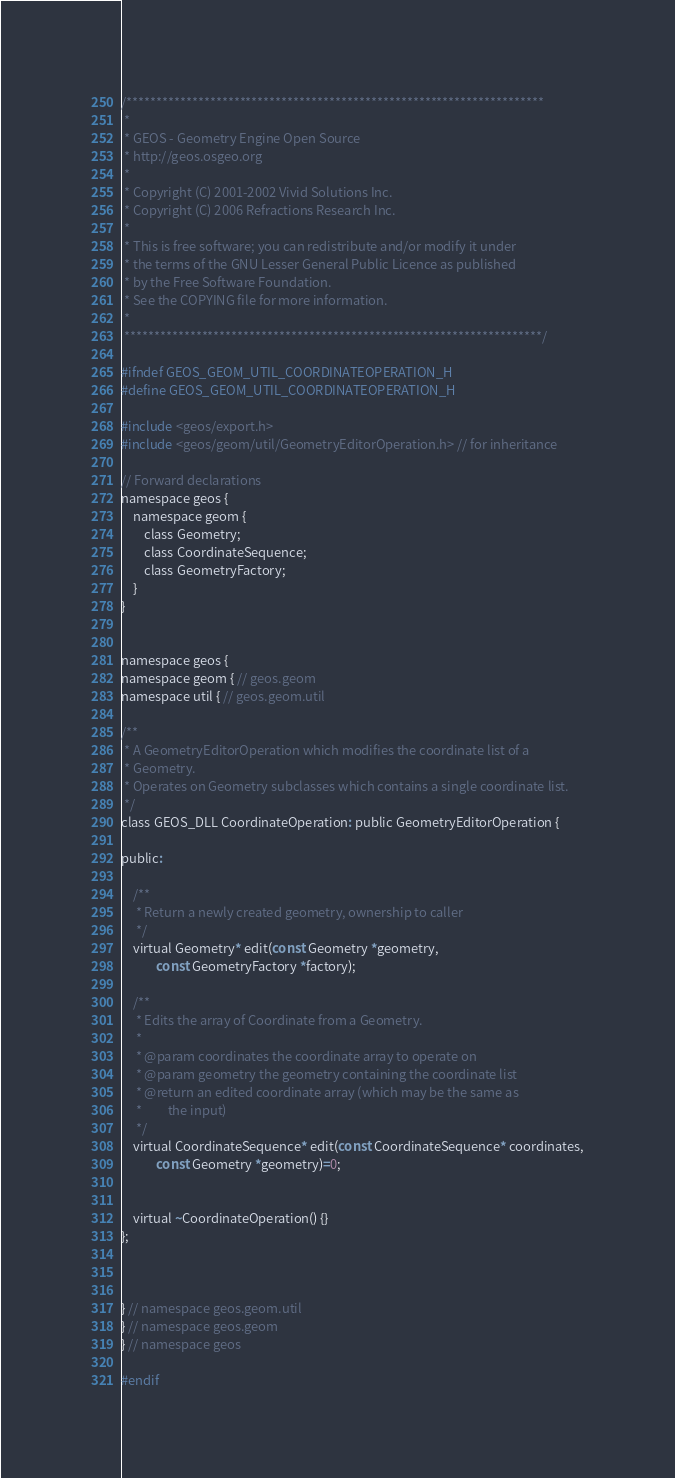Convert code to text. <code><loc_0><loc_0><loc_500><loc_500><_C_>/**********************************************************************
 *
 * GEOS - Geometry Engine Open Source
 * http://geos.osgeo.org
 *
 * Copyright (C) 2001-2002 Vivid Solutions Inc.
 * Copyright (C) 2006 Refractions Research Inc.
 *
 * This is free software; you can redistribute and/or modify it under
 * the terms of the GNU Lesser General Public Licence as published
 * by the Free Software Foundation. 
 * See the COPYING file for more information.
 *
 **********************************************************************/

#ifndef GEOS_GEOM_UTIL_COORDINATEOPERATION_H
#define GEOS_GEOM_UTIL_COORDINATEOPERATION_H

#include <geos/export.h>
#include <geos/geom/util/GeometryEditorOperation.h> // for inheritance

// Forward declarations
namespace geos {
	namespace geom {
		class Geometry;
		class CoordinateSequence;
		class GeometryFactory;
	}
}


namespace geos {
namespace geom { // geos.geom
namespace util { // geos.geom.util

/**
 * A GeometryEditorOperation which modifies the coordinate list of a
 * Geometry.
 * Operates on Geometry subclasses which contains a single coordinate list.
 */
class GEOS_DLL CoordinateOperation: public GeometryEditorOperation {

public:

	/**
	 * Return a newly created geometry, ownership to caller
	 */
	virtual Geometry* edit(const Geometry *geometry,
			const GeometryFactory *factory);

	/**
	 * Edits the array of Coordinate from a Geometry.
	 *
	 * @param coordinates the coordinate array to operate on
	 * @param geometry the geometry containing the coordinate list
	 * @return an edited coordinate array (which may be the same as
	 *         the input)
	 */
	virtual CoordinateSequence* edit(const CoordinateSequence* coordinates,
			const Geometry *geometry)=0;


	virtual ~CoordinateOperation() {}
};



} // namespace geos.geom.util
} // namespace geos.geom
} // namespace geos

#endif
</code> 